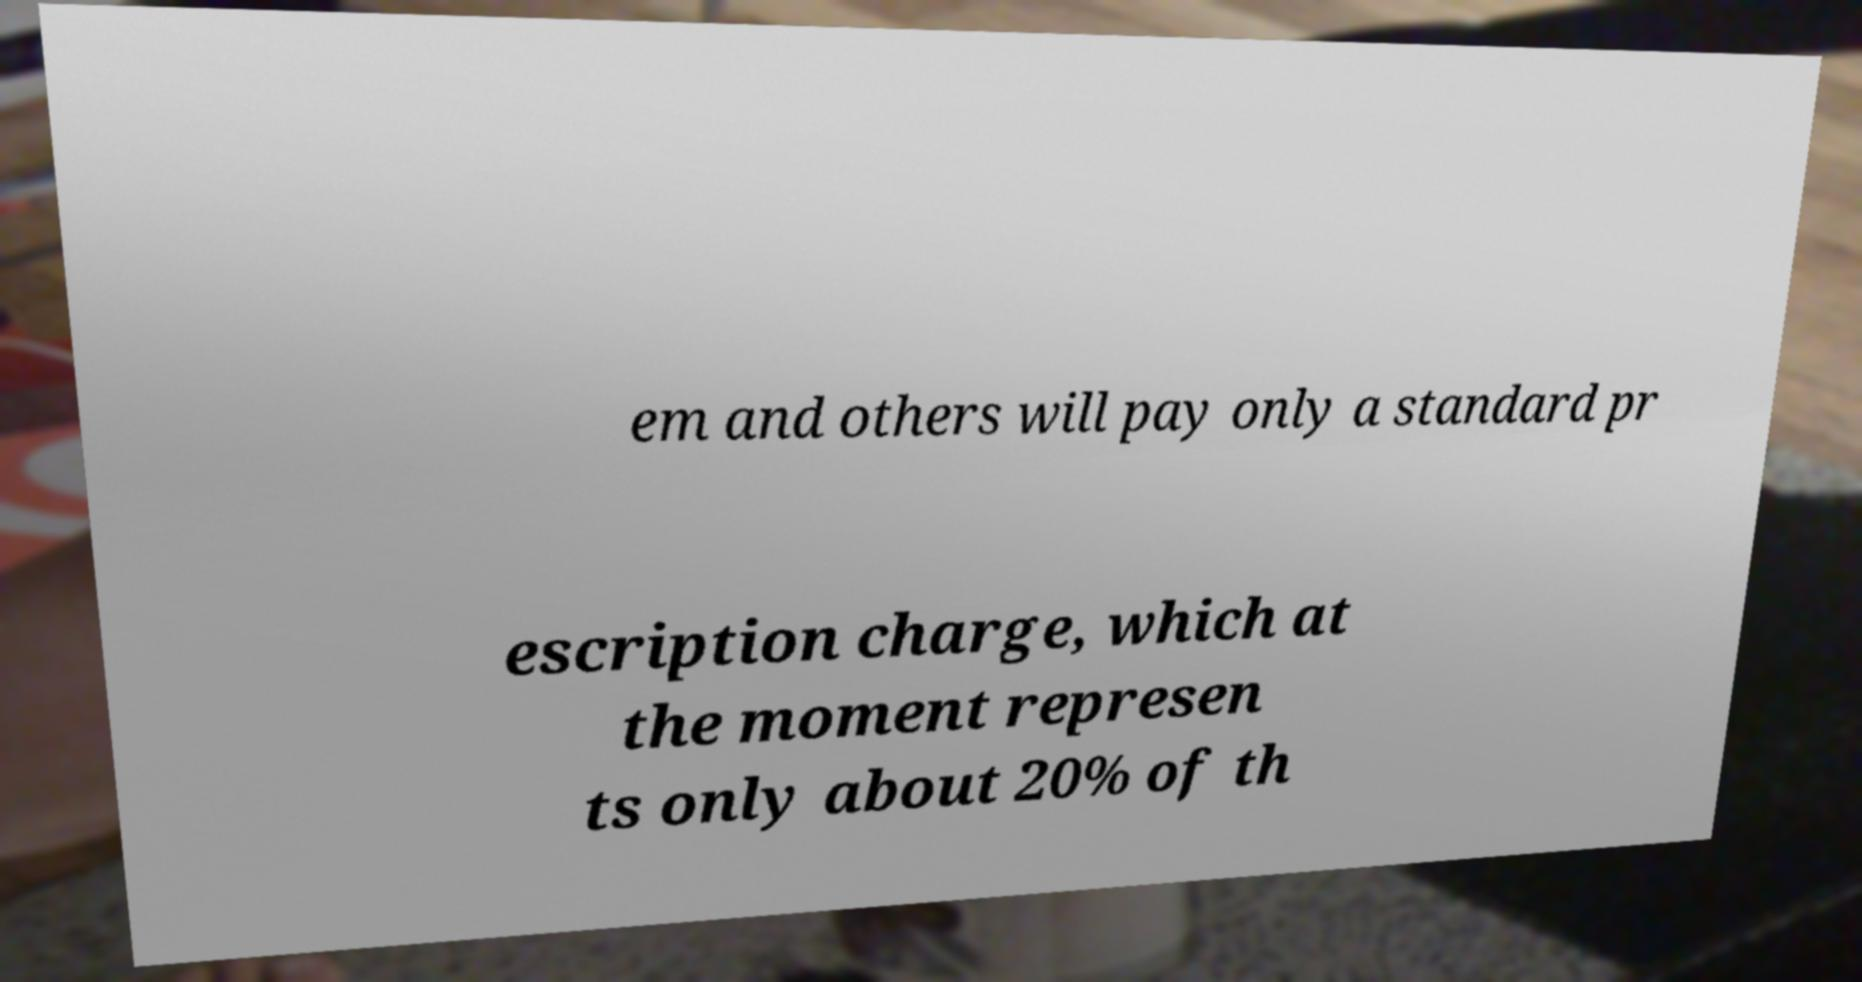There's text embedded in this image that I need extracted. Can you transcribe it verbatim? em and others will pay only a standard pr escription charge, which at the moment represen ts only about 20% of th 